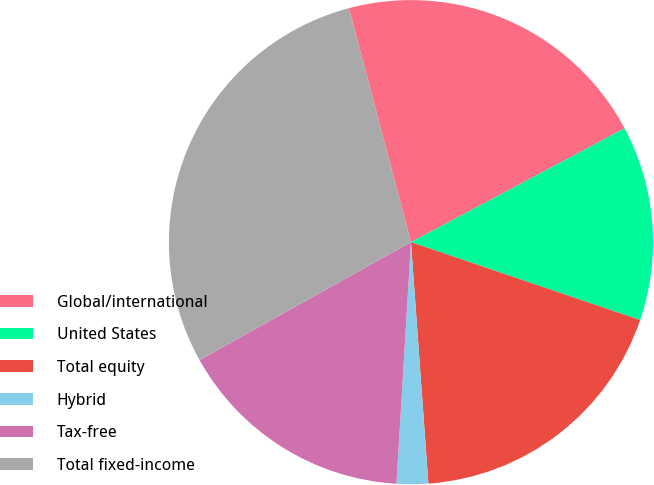Convert chart to OTSL. <chart><loc_0><loc_0><loc_500><loc_500><pie_chart><fcel>Global/international<fcel>United States<fcel>Total equity<fcel>Hybrid<fcel>Tax-free<fcel>Total fixed-income<nl><fcel>21.33%<fcel>13.01%<fcel>18.64%<fcel>2.1%<fcel>15.95%<fcel>28.97%<nl></chart> 